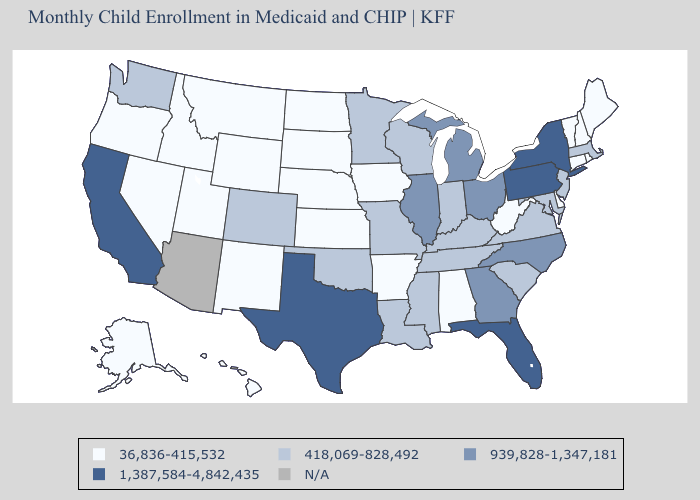Name the states that have a value in the range N/A?
Short answer required. Arizona. Name the states that have a value in the range 36,836-415,532?
Keep it brief. Alabama, Alaska, Arkansas, Connecticut, Delaware, Hawaii, Idaho, Iowa, Kansas, Maine, Montana, Nebraska, Nevada, New Hampshire, New Mexico, North Dakota, Oregon, Rhode Island, South Dakota, Utah, Vermont, West Virginia, Wyoming. What is the value of Kentucky?
Write a very short answer. 418,069-828,492. Does North Dakota have the lowest value in the USA?
Give a very brief answer. Yes. What is the value of South Carolina?
Answer briefly. 418,069-828,492. Which states have the lowest value in the USA?
Concise answer only. Alabama, Alaska, Arkansas, Connecticut, Delaware, Hawaii, Idaho, Iowa, Kansas, Maine, Montana, Nebraska, Nevada, New Hampshire, New Mexico, North Dakota, Oregon, Rhode Island, South Dakota, Utah, Vermont, West Virginia, Wyoming. Is the legend a continuous bar?
Keep it brief. No. Name the states that have a value in the range 418,069-828,492?
Give a very brief answer. Colorado, Indiana, Kentucky, Louisiana, Maryland, Massachusetts, Minnesota, Mississippi, Missouri, New Jersey, Oklahoma, South Carolina, Tennessee, Virginia, Washington, Wisconsin. Is the legend a continuous bar?
Give a very brief answer. No. Which states have the highest value in the USA?
Write a very short answer. California, Florida, New York, Pennsylvania, Texas. What is the value of Nebraska?
Give a very brief answer. 36,836-415,532. Name the states that have a value in the range 1,387,584-4,842,435?
Answer briefly. California, Florida, New York, Pennsylvania, Texas. What is the highest value in states that border South Carolina?
Answer briefly. 939,828-1,347,181. 